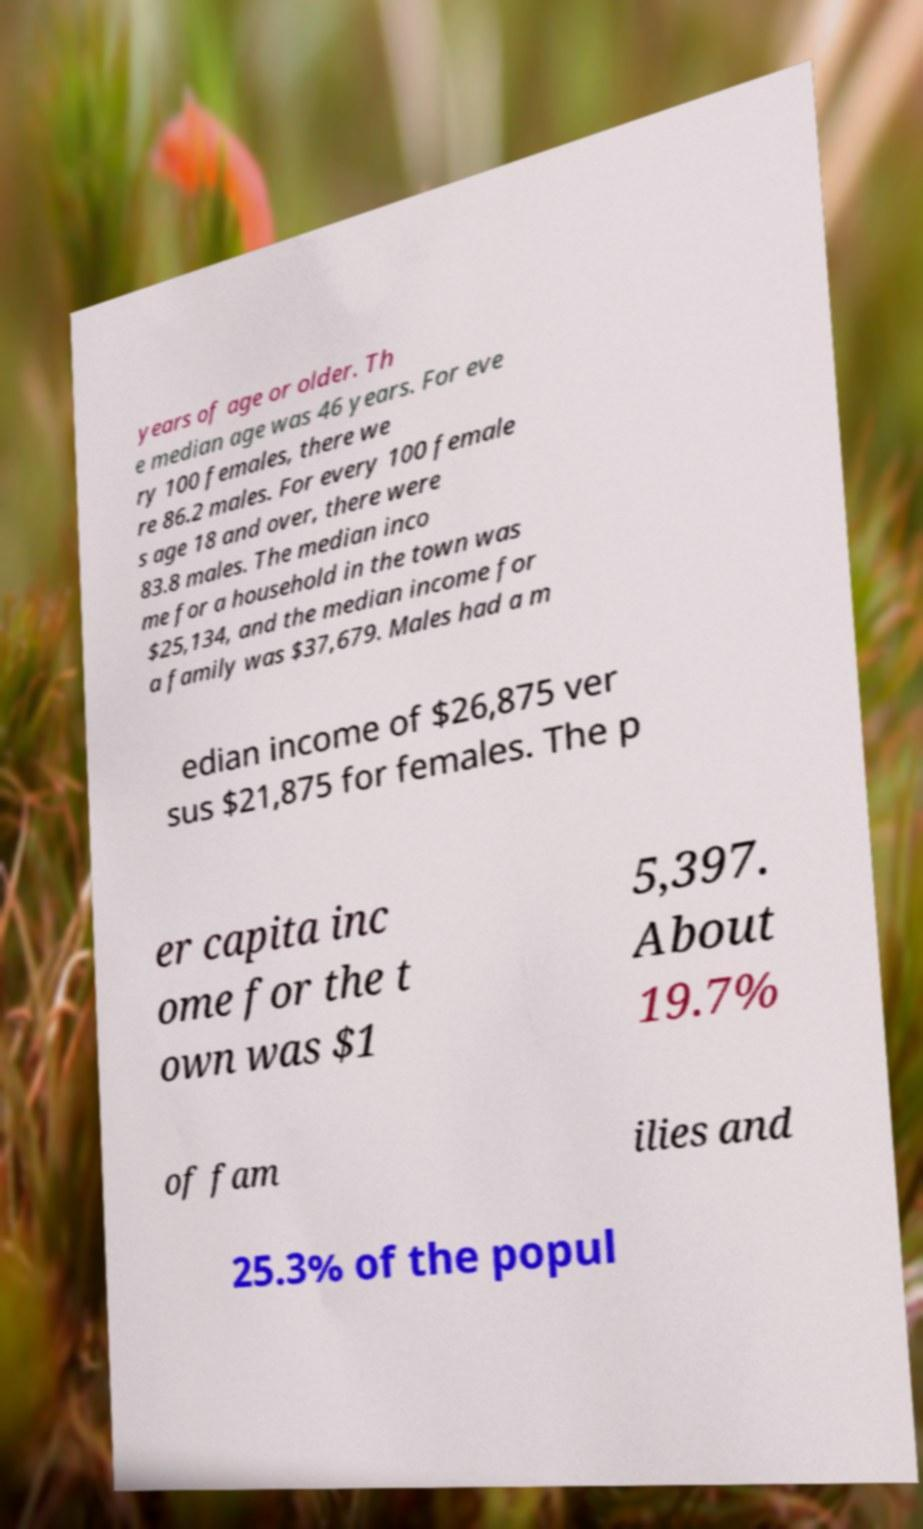Could you assist in decoding the text presented in this image and type it out clearly? years of age or older. Th e median age was 46 years. For eve ry 100 females, there we re 86.2 males. For every 100 female s age 18 and over, there were 83.8 males. The median inco me for a household in the town was $25,134, and the median income for a family was $37,679. Males had a m edian income of $26,875 ver sus $21,875 for females. The p er capita inc ome for the t own was $1 5,397. About 19.7% of fam ilies and 25.3% of the popul 